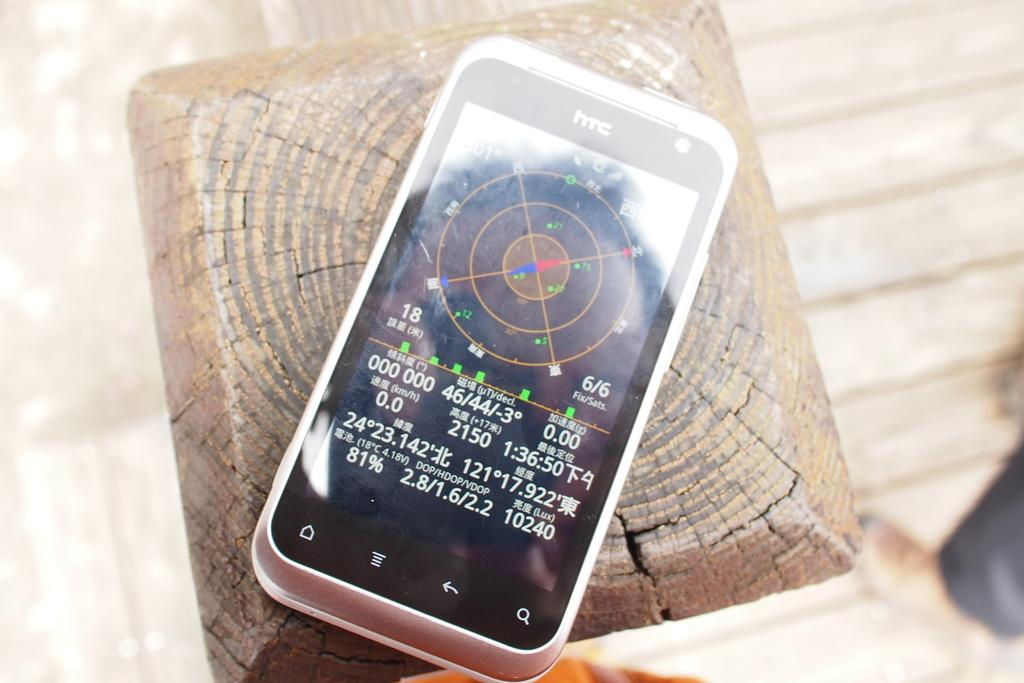<image>
Share a concise interpretation of the image provided. a white, silver and black htc phone that has numbers like '2150' on it 